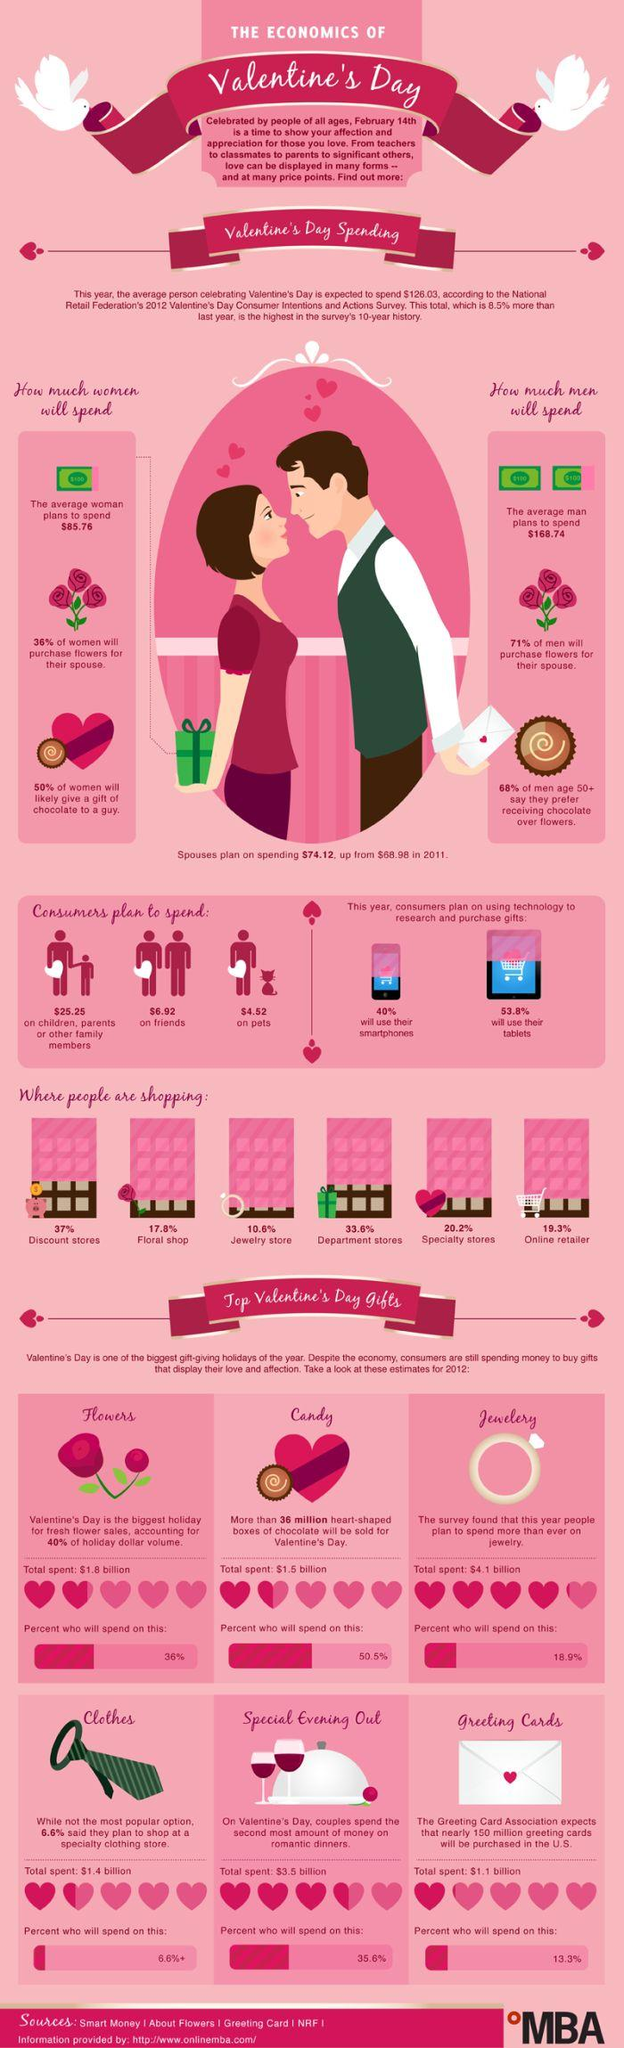Mention a couple of crucial points in this snapshot. A majority of consumers, 40%, will use their smartphones to purchase gifts for their loved ones. According to a recent survey, 53.8% of consumers plan to use tablets to purchase gifts for their loved ones this holiday season. On Valentine's Day, the total amount spent on heart-shaped boxes of candies is estimated to be $1.5 billion. According to a recent survey, it is expected that 50.5% of people will gift candies for Valentine's day. A significant majority of men preferred chocolate as a gift over flowers. 